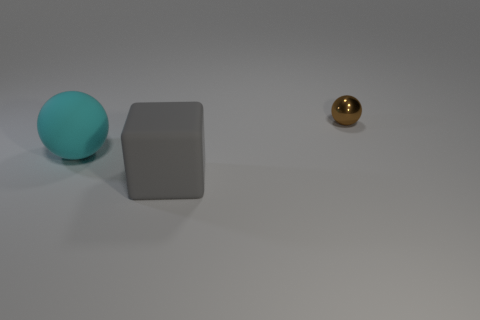Add 2 tiny cyan rubber cubes. How many objects exist? 5 Subtract all cyan spheres. How many spheres are left? 1 Subtract 0 yellow balls. How many objects are left? 3 Subtract all blocks. How many objects are left? 2 Subtract all brown spheres. Subtract all metal balls. How many objects are left? 1 Add 2 large rubber blocks. How many large rubber blocks are left? 3 Add 2 balls. How many balls exist? 4 